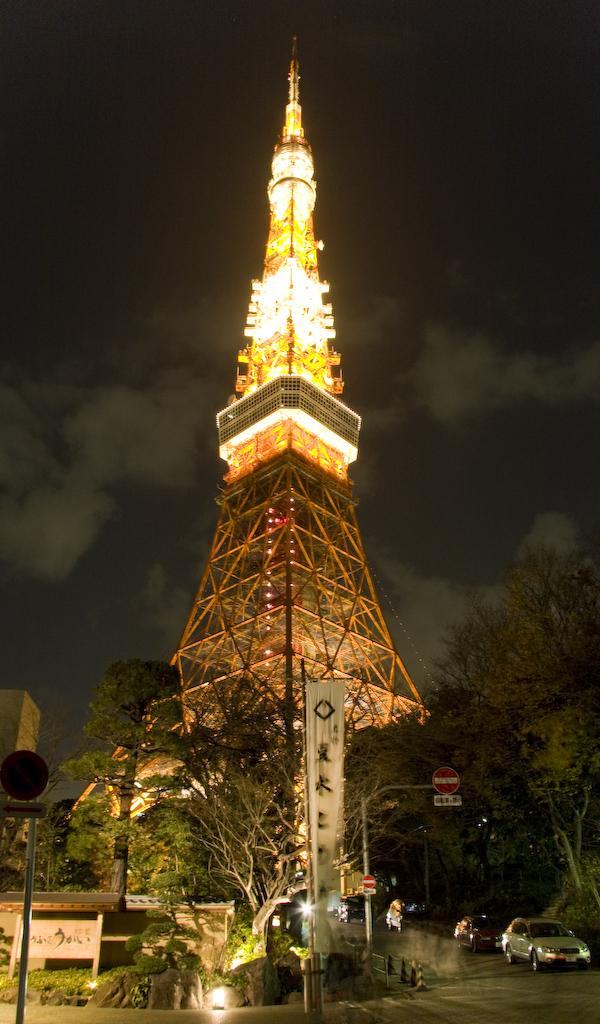What is the main structure in the image? There is a tower in the image. What surrounds the tower? There are trees on either side of the tower. What is in the middle of the image? There is a road in the middle of the image. What is happening on the road? Vehicles are moving on the road. What is the low value of the control tower in the image? There is no control tower mentioned in the image, and the concept of value does not apply to the tower. 